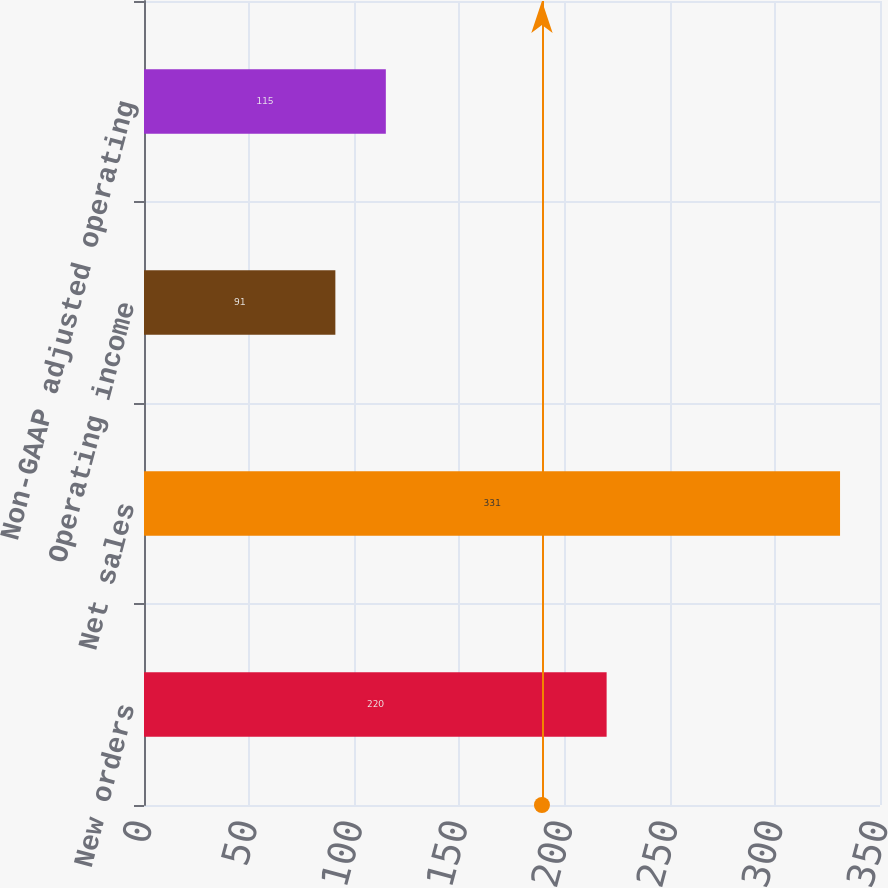Convert chart to OTSL. <chart><loc_0><loc_0><loc_500><loc_500><bar_chart><fcel>New orders<fcel>Net sales<fcel>Operating income<fcel>Non-GAAP adjusted operating<nl><fcel>220<fcel>331<fcel>91<fcel>115<nl></chart> 